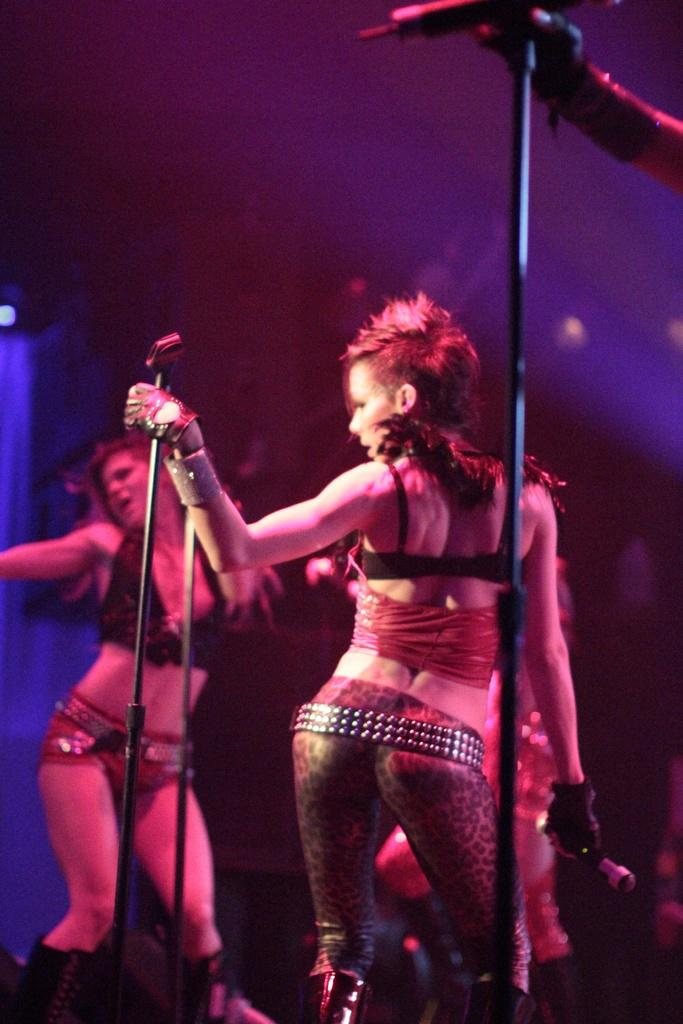How many women are in the image? There are two women in the image. What are the women doing in the image? The women are standing in the image. What are the women holding in their hands? The women are holding objects in their hands. What can be seen in the background of the image? The background of the image is dark. What type of structures are visible in the image? There are poles visible in the image. Can you describe any other objects in the image besides the women and poles? There are other unspecified objects in the image. What date is circled on the calendar in the image? There is no calendar present in the image. What type of secretary is assisting the women in the image? There is no secretary present in the image. 